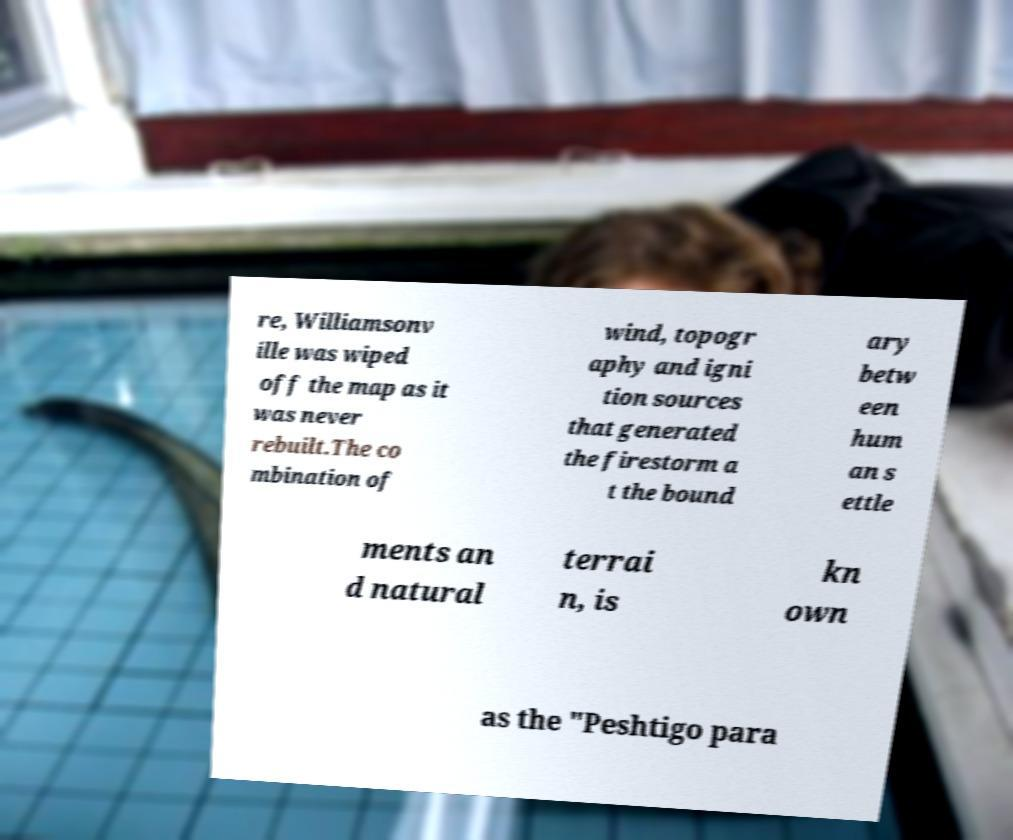I need the written content from this picture converted into text. Can you do that? re, Williamsonv ille was wiped off the map as it was never rebuilt.The co mbination of wind, topogr aphy and igni tion sources that generated the firestorm a t the bound ary betw een hum an s ettle ments an d natural terrai n, is kn own as the "Peshtigo para 